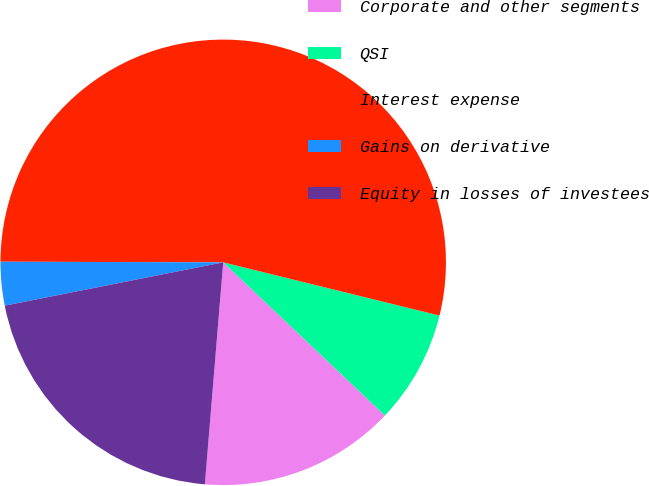Convert chart to OTSL. <chart><loc_0><loc_0><loc_500><loc_500><pie_chart><fcel>Corporate and other segments<fcel>QSI<fcel>Interest expense<fcel>Gains on derivative<fcel>Equity in losses of investees<nl><fcel>14.24%<fcel>8.23%<fcel>53.8%<fcel>3.16%<fcel>20.57%<nl></chart> 